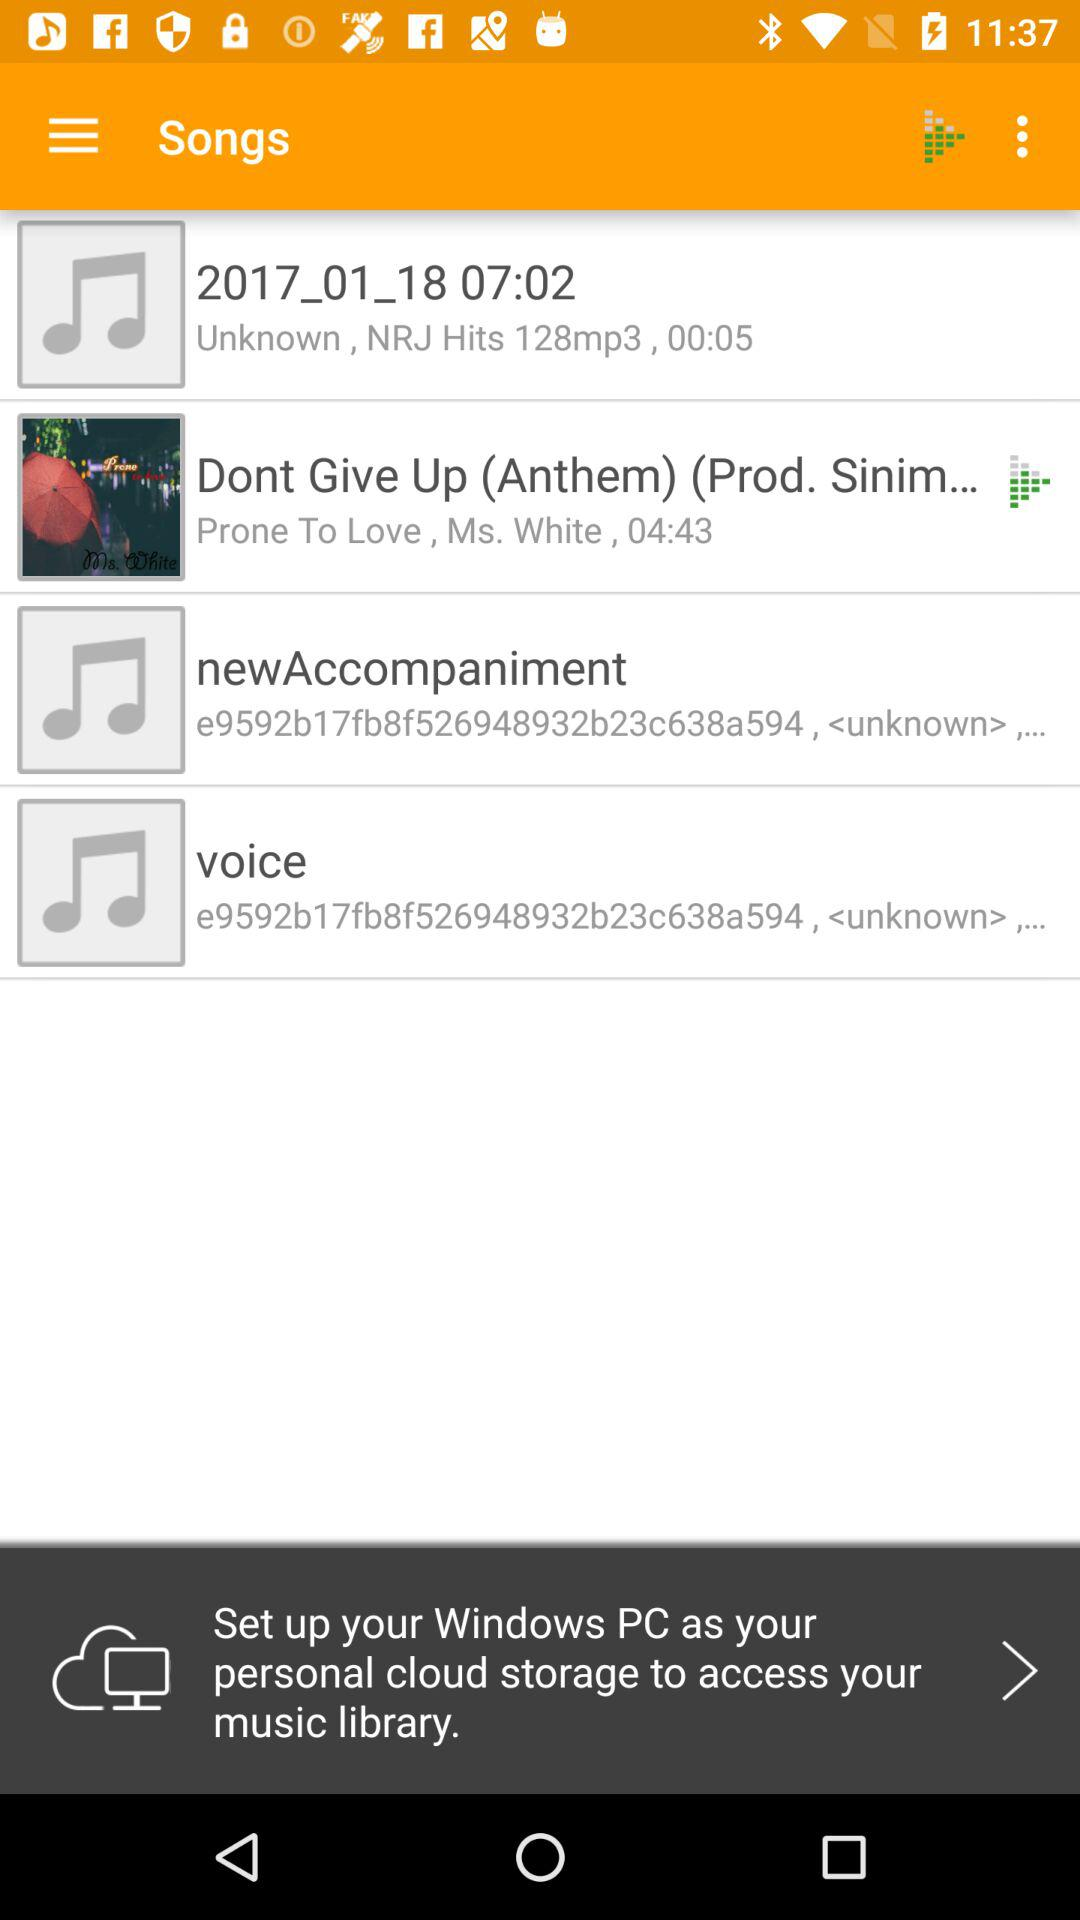Who is the artist of the "Dont Give Up (Anthem)"? The artist is "Ms. White". 